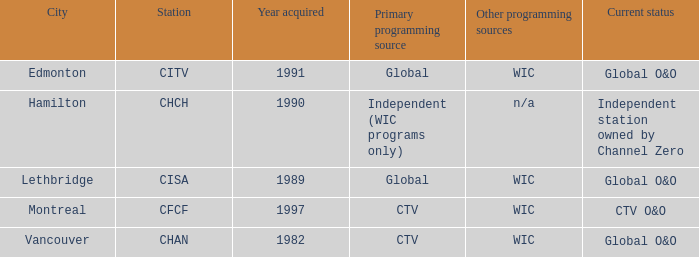How much were gathered as the chan? 1.0. 